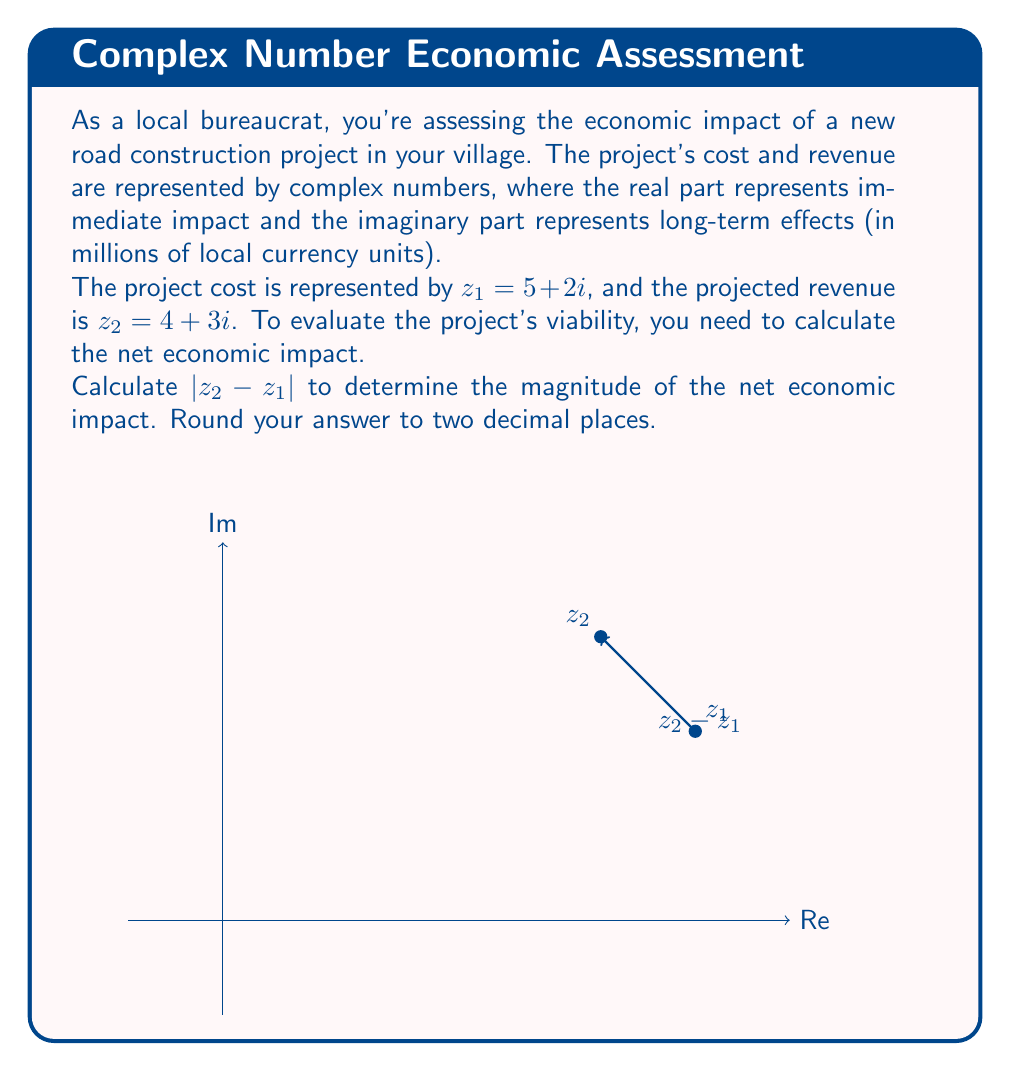Provide a solution to this math problem. Let's approach this step-by-step:

1) First, we need to calculate $z_2 - z_1$:
   $z_2 - z_1 = (4 + 3i) - (5 + 2i)$
   $= 4 + 3i - 5 - 2i$
   $= -1 + i$

2) Now, we need to find the magnitude of this complex number. The magnitude of a complex number $a + bi$ is given by $\sqrt{a^2 + b^2}$.

3) In this case, we have $-1 + i$, so $a = -1$ and $b = 1$.

4) Let's calculate $|z_2 - z_1|$:
   $|z_2 - z_1| = \sqrt{(-1)^2 + 1^2}$
   $= \sqrt{1 + 1}$
   $= \sqrt{2}$

5) $\sqrt{2} \approx 1.4142...$

6) Rounding to two decimal places, we get 1.41.

This result represents the magnitude of the net economic impact of the project, combining both immediate and long-term effects.
Answer: $1.41$ 